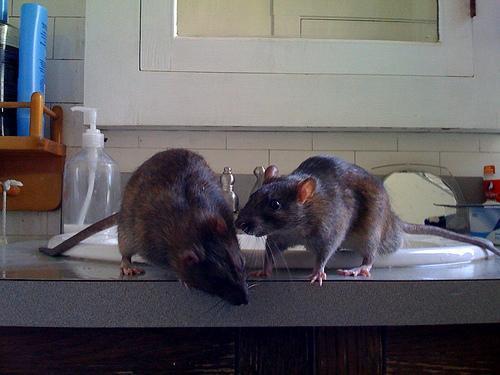How many mice are they?
Give a very brief answer. 2. 